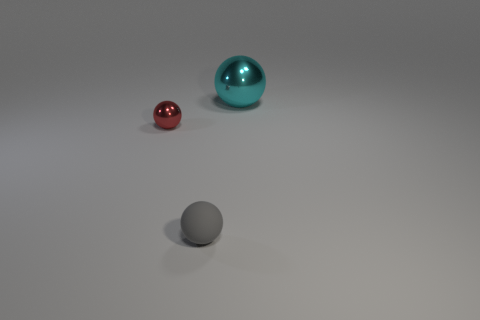Add 3 tiny metallic things. How many objects exist? 6 Subtract all gray spheres. How many spheres are left? 2 Add 1 small objects. How many small objects exist? 3 Subtract 0 gray cubes. How many objects are left? 3 Subtract all blue balls. Subtract all purple blocks. How many balls are left? 3 Subtract all yellow matte balls. Subtract all big things. How many objects are left? 2 Add 3 small gray spheres. How many small gray spheres are left? 4 